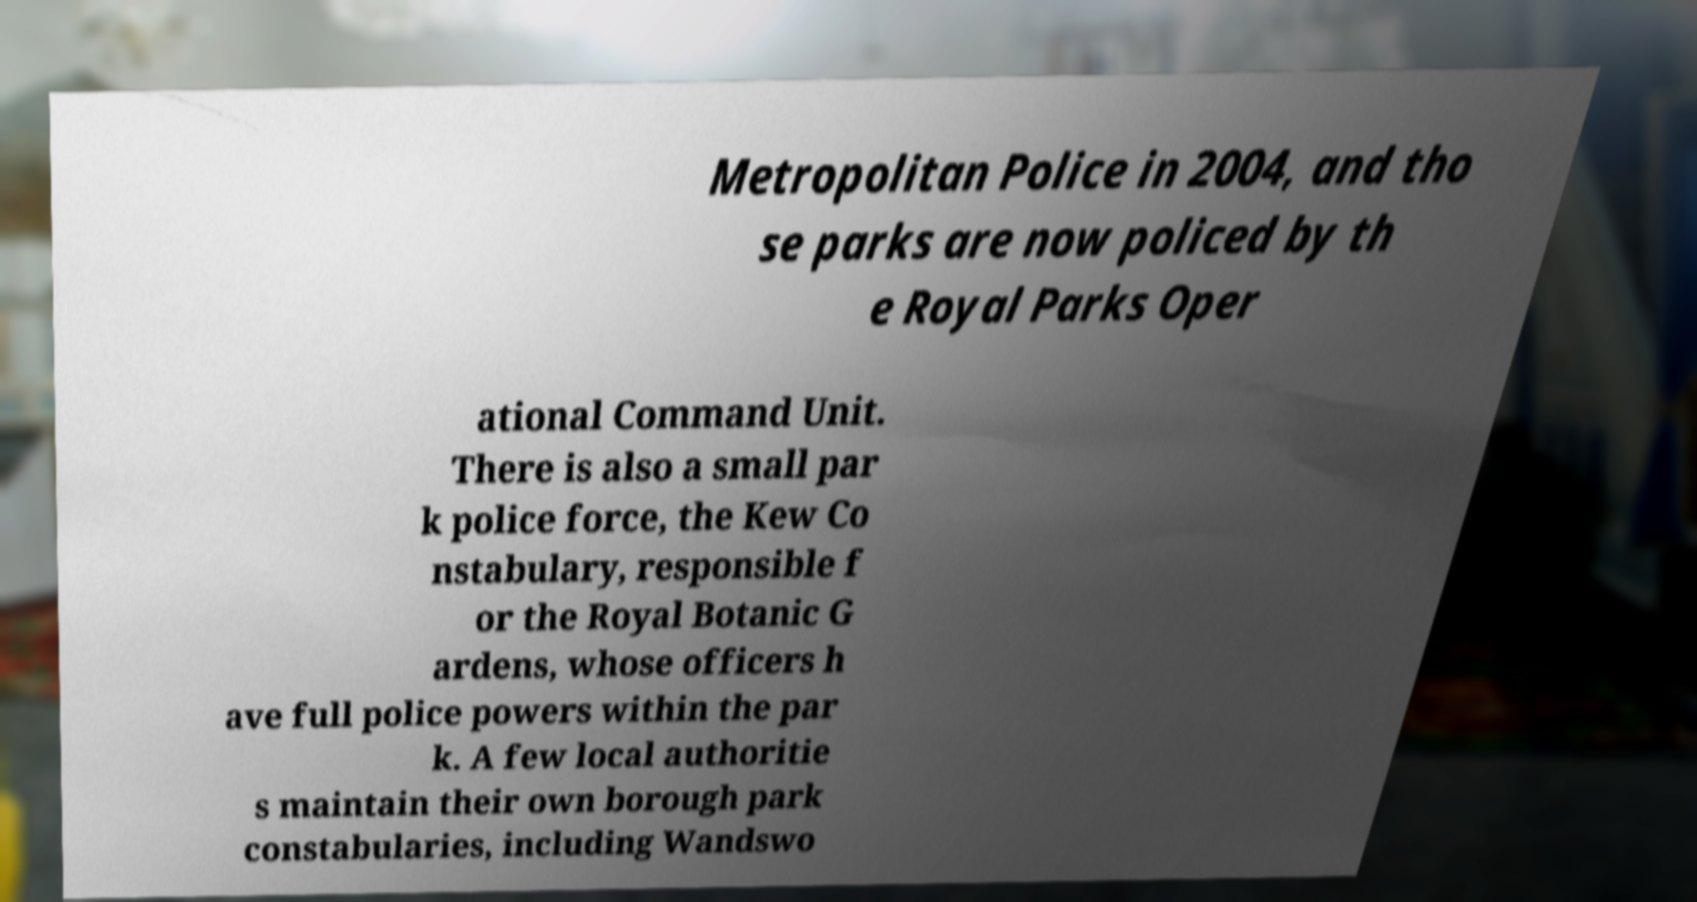There's text embedded in this image that I need extracted. Can you transcribe it verbatim? Metropolitan Police in 2004, and tho se parks are now policed by th e Royal Parks Oper ational Command Unit. There is also a small par k police force, the Kew Co nstabulary, responsible f or the Royal Botanic G ardens, whose officers h ave full police powers within the par k. A few local authoritie s maintain their own borough park constabularies, including Wandswo 